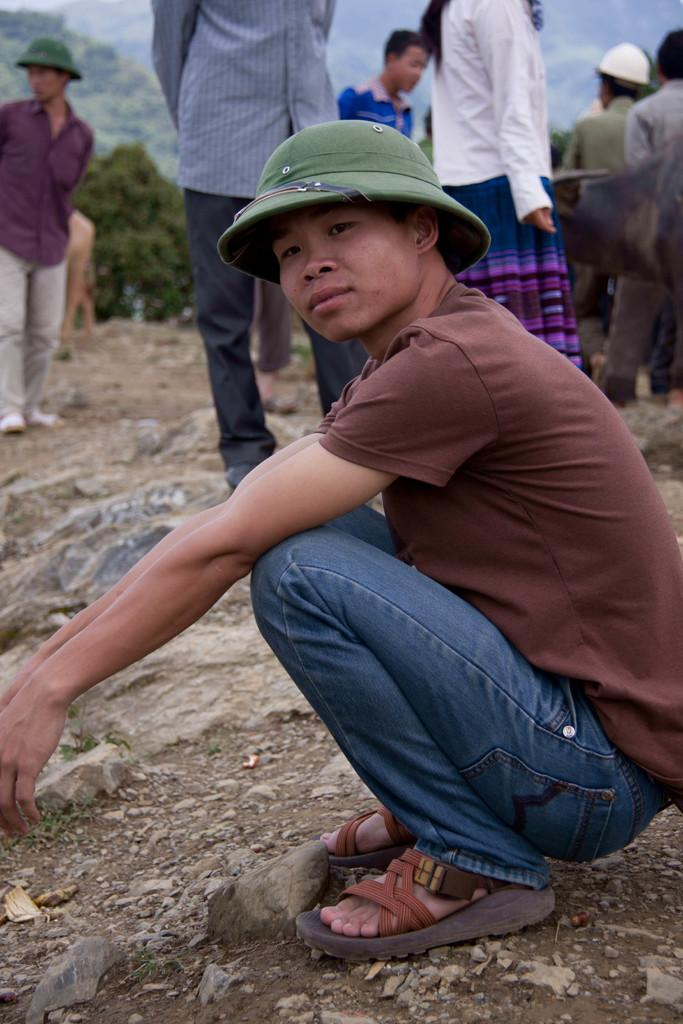What is the boy in the image doing? The boy is sitting on the ground in the image. Can you describe the boy's clothing? The boy is wearing a green hat. What can be seen behind the boy? There are other persons standing behind the boy. What is visible in the background of the image? There are trees in the background of the image. Is the boy participating in a battle in the image? There is no indication of a battle in the image; the boy is simply sitting on the ground with other persons standing behind him. Can you tell me how deep the river is in the image? There is no river present in the image; it features a boy sitting on the ground, wearing a green hat, with other persons standing behind him and trees in the background. 